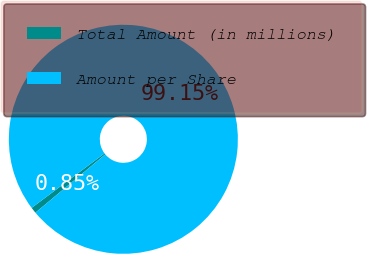Convert chart to OTSL. <chart><loc_0><loc_0><loc_500><loc_500><pie_chart><fcel>Total Amount (in millions)<fcel>Amount per Share<nl><fcel>0.85%<fcel>99.15%<nl></chart> 